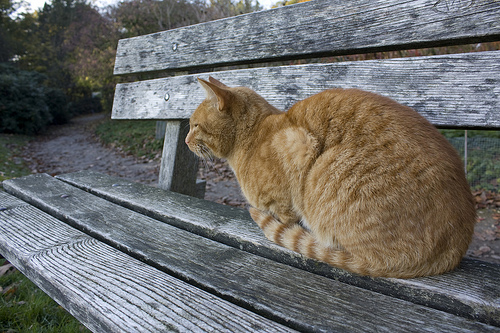Do you see either any black birds or cats? No black birds or black-colored cats can be seen in the image. 